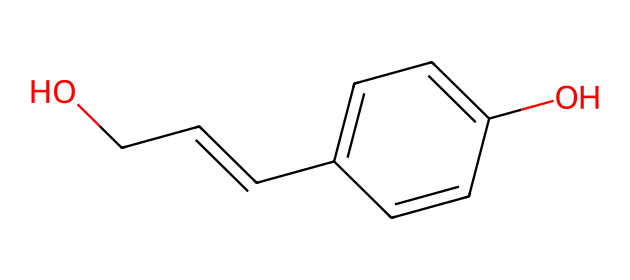What is the main functional group present in this compound? The compound shows a hydroxyl group (-OH), which is represented in the structure. This indicates that the main functional group is alcoholic.
Answer: alcoholic How many carbon atoms are in the molecule? Counting the carbon atoms from the SMILES representation, there are eight carbon atoms present in the structure.
Answer: eight What type of isomerism might this compound exhibit? The compound contains a double bond (indicated by the "C=C" structure), which allows for cis-trans isomerism. Additionally, there are multiple functional groups which can lead to structural isomerism.
Answer: cis-trans isomerism What is the molecular framework of this chemical? The structure suggests a framework based on aromatic rings because of the presence of alternating single and double bonds along with the attached functional groups.
Answer: aromatic Does this compound include any functional groups besides the alcohol? Besides the hydroxyl group, there is an alkene present in the compound (due to the C=C bond) which indicates the presence of unsaturation in the carbon chain.
Answer: yes, alkene 